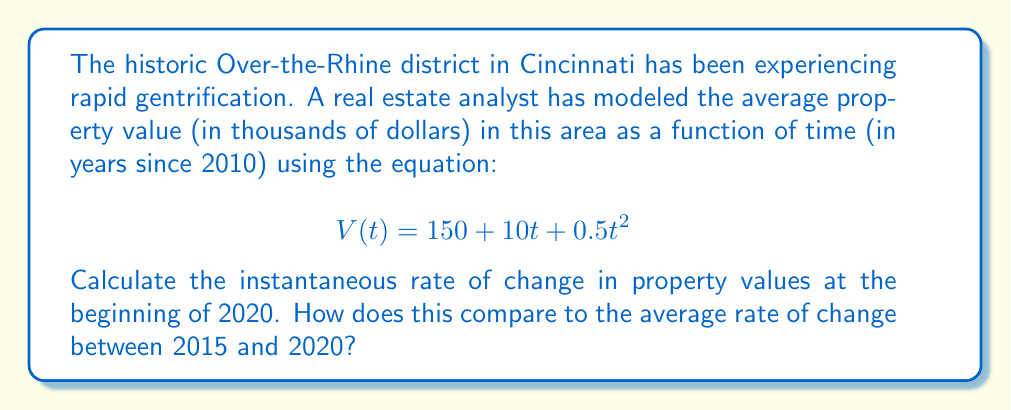Teach me how to tackle this problem. To solve this problem, we need to use derivatives to find the instantaneous rate of change and the average rate of change.

1. Instantaneous rate of change:
The instantaneous rate of change is given by the first derivative of the function V(t) at t = 10 (2020 is 10 years after 2010).

First, let's find the derivative of V(t):
$$V'(t) = 10 + t$$

Now, we evaluate V'(10):
$$V'(10) = 10 + 10 = 20$$

This means that at the beginning of 2020, property values were increasing at a rate of $20,000 per year.

2. Average rate of change:
The average rate of change between 2015 and 2020 is calculated using the formula:

$$\text{Average rate of change} = \frac{V(2020) - V(2015)}{2020 - 2015}$$

Let's calculate V(10) for 2020 and V(5) for 2015:

V(10) = 150 + 10(10) + 0.5(10)^2 = 150 + 100 + 50 = 300
V(5) = 150 + 10(5) + 0.5(5)^2 = 150 + 50 + 12.5 = 212.5

Now we can calculate the average rate of change:

$$\text{Average rate of change} = \frac{300 - 212.5}{5} = 17.5$$

This means that between 2015 and 2020, property values increased by an average of $17,500 per year.

Comparing the two rates:
The instantaneous rate of change in 2020 ($20,000 per year) is higher than the average rate of change between 2015 and 2020 ($17,500 per year). This indicates that the rate of increase in property values is accelerating.
Answer: The instantaneous rate of change in property values at the beginning of 2020 is $20,000 per year. The average rate of change between 2015 and 2020 is $17,500 per year. The instantaneous rate is higher, indicating an acceleration in property value increases. 